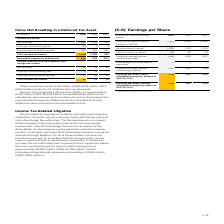According to Sap Ag's financial document, How much of unused tax losses relate to U.S. state tax loss carryforwards in 2019? According to the financial document, €187 million. The relevant text states: "Of the unused tax losses, €187 million (2018: €213 million; 2017:..." Also, What was the Total unused tax credits in 2019? According to the financial document, 45 (in millions). The relevant text states: "Total unused tax credits 45 72 74..." Also, In which years were the total unused tax losses calculated? The document contains multiple relevant values: 2019, 2018, 2017. From the document: "€ millions 2019 2018 2017 € millions 2019 2018 2017 € millions 2019 2018 2017..." Additionally, In which year was the amount Expiring after the following year the largest? According to the financial document, 2017. The relevant text states: "€ millions 2019 2018 2017..." Also, can you calculate: What was the change in the amount Expiring after the following year in 2019 from 2018? Based on the calculation: 17-18, the result is -1 (in millions). This is based on the information: "€ millions 2019 2018 2017 € millions 2019 2018 2017..." The key data points involved are: 17, 18. Also, can you calculate: What was the percentage change in the amount Expiring after the following year in 2019 from 2018? To answer this question, I need to perform calculations using the financial data. The calculation is: (17-18)/18, which equals -5.56 (percentage). This is based on the information: "€ millions 2019 2018 2017 € millions 2019 2018 2017..." The key data points involved are: 17, 18. 